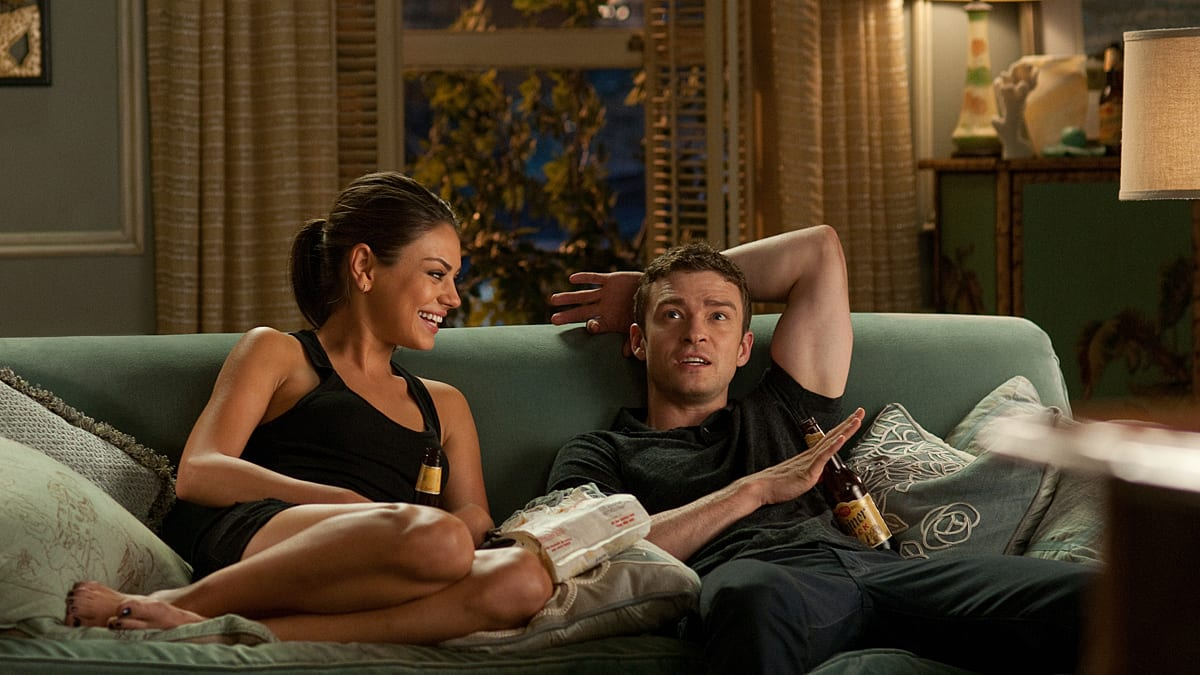Could you describe some of the decor elements in the living room? The living room is tastefully decorated with a blend of modern and traditional elements. The large, soft green sofa provides a central focus, while patterned throw pillows and a cozy white blanket add comfort and style. Behind the couch, the window treatments consist of neutral-colored curtains paired with sheer drapes that suggest a layered approach to privacy and lighting. The side table lamps have classic designs, emitting a warm glow that enhances the homely ambiance. Ancillary details such as the intricate picture frame and ornamental plants further personalize the space, creating an inviting and lived-in look. 